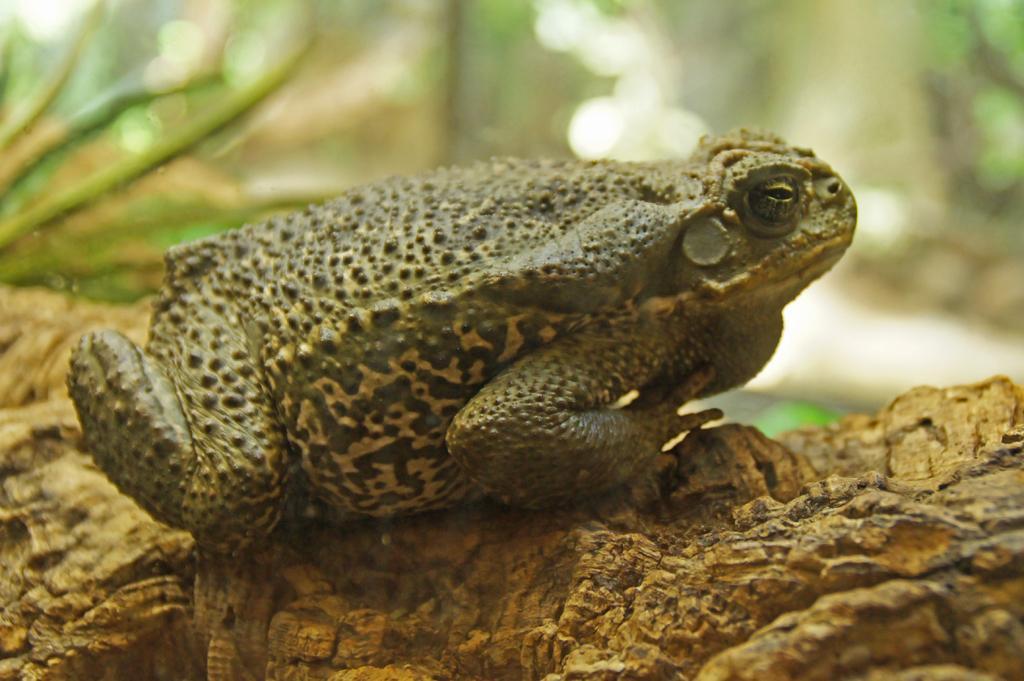How would you summarize this image in a sentence or two? In this image we can see a frog on the ground. In the background, we can see some plants. 